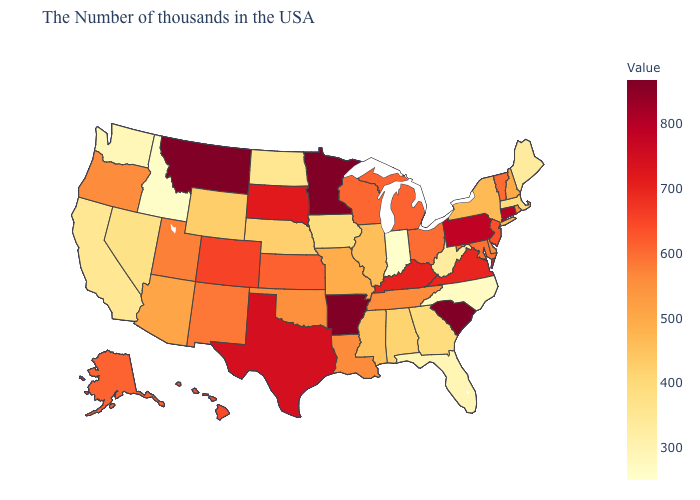Which states hav the highest value in the Northeast?
Answer briefly. Connecticut. Among the states that border Missouri , which have the highest value?
Answer briefly. Arkansas. Does Indiana have the lowest value in the MidWest?
Be succinct. Yes. Which states have the highest value in the USA?
Quick response, please. South Carolina, Arkansas, Minnesota, Montana. Among the states that border Kentucky , does Indiana have the highest value?
Keep it brief. No. Among the states that border Colorado , which have the lowest value?
Keep it brief. Nebraska. Which states have the lowest value in the South?
Be succinct. North Carolina. Which states have the highest value in the USA?
Short answer required. South Carolina, Arkansas, Minnesota, Montana. 